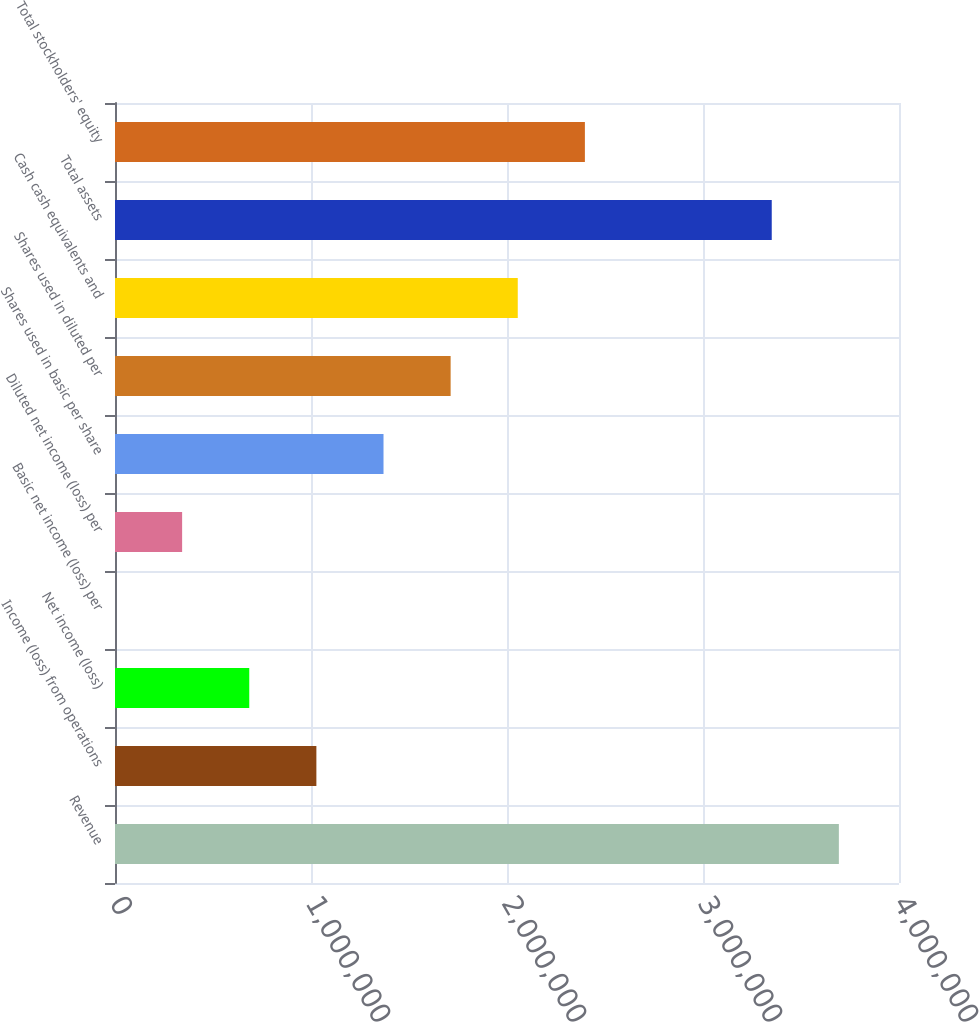Convert chart. <chart><loc_0><loc_0><loc_500><loc_500><bar_chart><fcel>Revenue<fcel>Income (loss) from operations<fcel>Net income (loss)<fcel>Basic net income (loss) per<fcel>Diluted net income (loss) per<fcel>Shares used in basic per share<fcel>Shares used in diluted per<fcel>Cash cash equivalents and<fcel>Total assets<fcel>Total stockholders' equity<nl><fcel>3.69321e+06<fcel>1.02746e+06<fcel>684972<fcel>0.05<fcel>342486<fcel>1.36994e+06<fcel>1.71243e+06<fcel>2.05492e+06<fcel>3.35073e+06<fcel>2.3974e+06<nl></chart> 